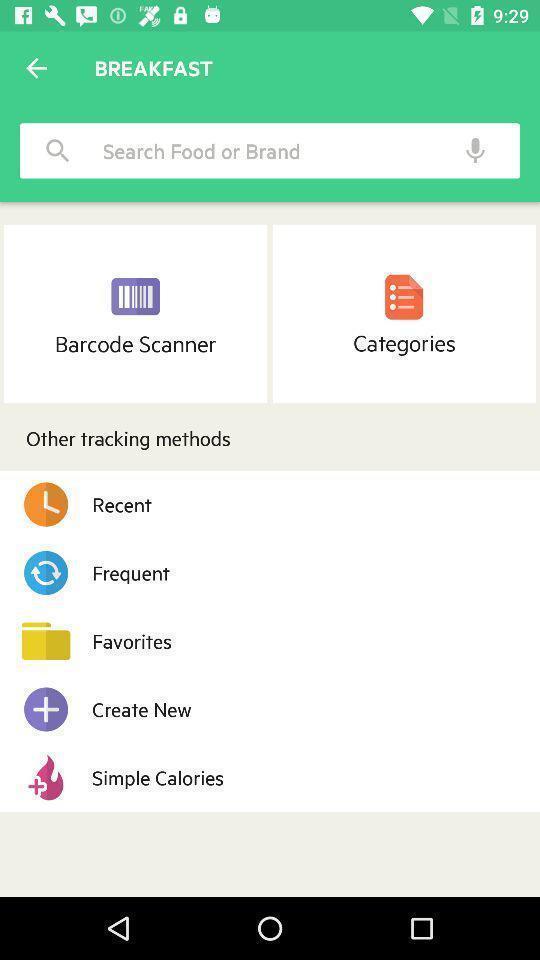What can you discern from this picture? Search bar to find food for breakfast. 